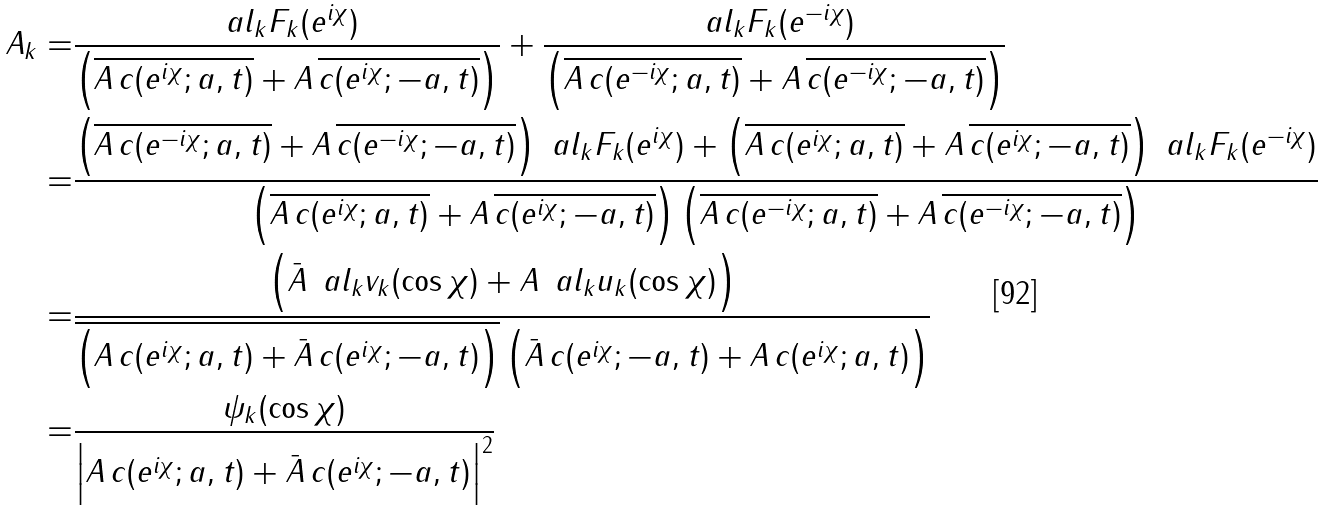<formula> <loc_0><loc_0><loc_500><loc_500>A _ { k } = & \frac { \ a l _ { k } F _ { k } ( e ^ { i \chi } ) } { \left ( \overline { A \, c ( e ^ { i \chi } ; a , t ) } + A \, \overline { c ( e ^ { i \chi } ; - a , t ) } \right ) } + \frac { \ a l _ { k } F _ { k } ( e ^ { - i \chi } ) } { \left ( \overline { A \, c ( e ^ { - i \chi } ; a , t ) } + A \, \overline { c ( e ^ { - i \chi } ; - a , t ) } \right ) } \\ = & \frac { \left ( \overline { A \, c ( e ^ { - i \chi } ; a , t ) } + A \, \overline { c ( e ^ { - i \chi } ; - a , t ) } \right ) \ a l _ { k } F _ { k } ( e ^ { i \chi } ) + \left ( \overline { A \, c ( e ^ { i \chi } ; a , t ) } + A \, \overline { c ( e ^ { i \chi } ; - a , t ) } \right ) \ a l _ { k } F _ { k } ( e ^ { - i \chi } ) } { \left ( \overline { A \, c ( e ^ { i \chi } ; a , t ) } + A \, \overline { c ( e ^ { i \chi } ; - a , t ) } \right ) \left ( \overline { A \, c ( e ^ { - i \chi } ; a , t ) } + A \, \overline { c ( e ^ { - i \chi } ; - a , t ) } \right ) } \\ = & \frac { \left ( \bar { A } \, \ a l _ { k } v _ { k } ( \cos \chi ) + A \, \ a l _ { k } u _ { k } ( \cos \chi ) \right ) } { \overline { \left ( A \, c ( e ^ { i \chi } ; a , t ) + \bar { A } \, c ( e ^ { i \chi } ; - a , t ) \right ) } \left ( \bar { A } \, c ( e ^ { i \chi } ; - a , t ) + A \, c ( e ^ { i \chi } ; a , t ) \right ) } \\ = & \frac { \psi _ { k } ( \cos \chi ) } { \left | A \, c ( e ^ { i \chi } ; a , t ) + \bar { A } \, c ( e ^ { i \chi } ; - a , t ) \right | ^ { 2 } }</formula> 